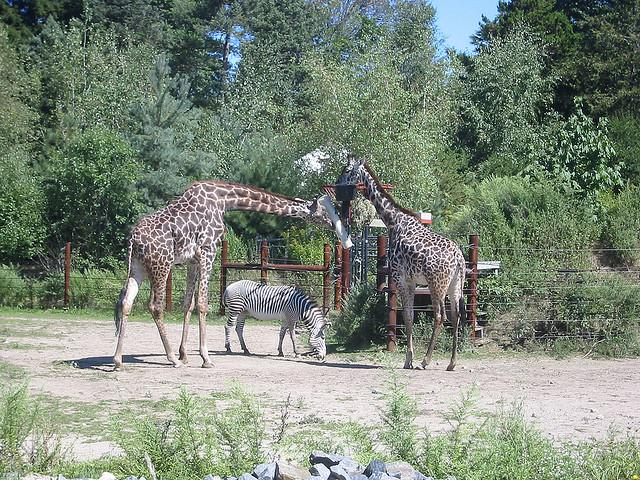What animal is between the giraffes? Please explain your reasoning. zebra. The animal has black and white stripes. 